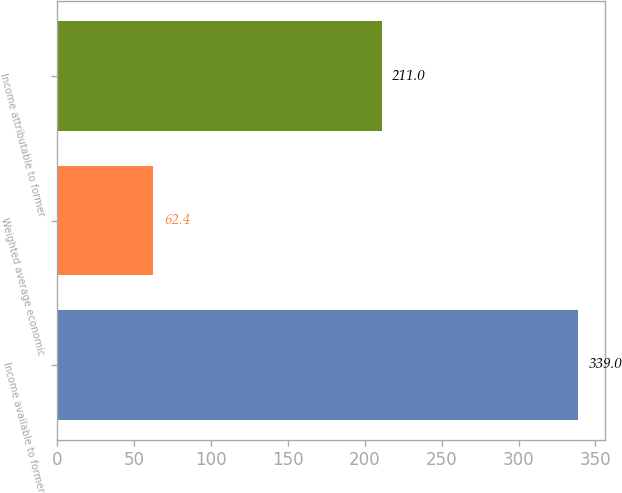Convert chart to OTSL. <chart><loc_0><loc_0><loc_500><loc_500><bar_chart><fcel>Income available to former<fcel>Weighted average economic<fcel>Income attributable to former<nl><fcel>339<fcel>62.4<fcel>211<nl></chart> 